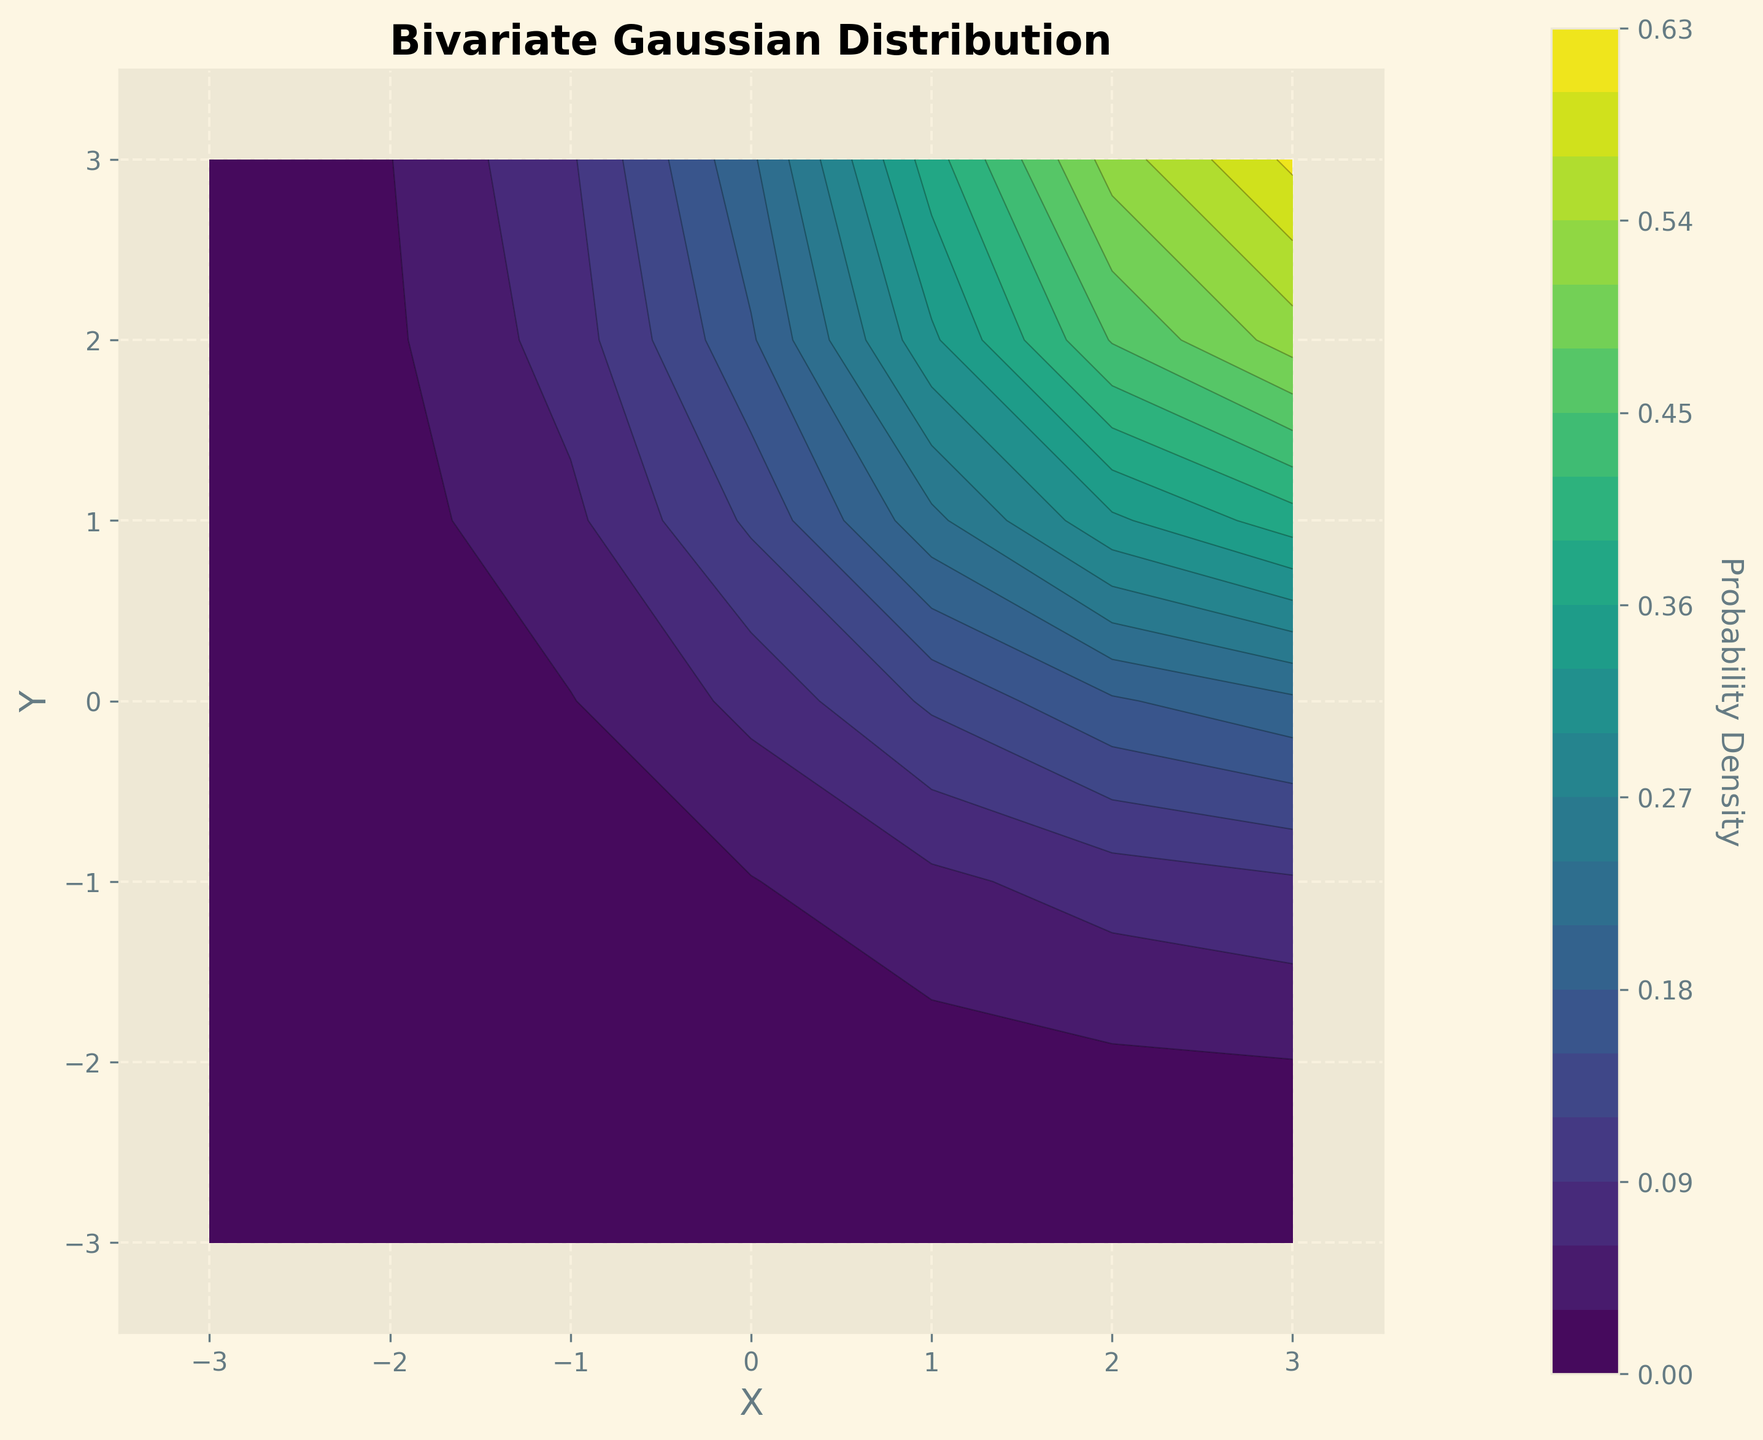What is the title of the figure? The title of the figure is displayed at the top and indicates what the plot represents. Looking at the label, we see the title is "Bivariate Gaussian Distribution."
Answer: Bivariate Gaussian Distribution What are the labels for the x-axis and y-axis? The labels for the axes are found directly adjacent to the respective axes along the plot margins. They indicate what the axes represent. The x-axis is labeled "X," and the y-axis is labeled "Y."
Answer: X and Y What does the color in the contour plot indicate? The contour plot uses color to represent different values on a continuous scale. The color bar on the right side of the plot indicates that the color represents the probability density values.
Answer: Probability Density Which color represents the highest probability density? Observing the color bar, the highest probability density is reflected by the color at the top end of the scale. In this case, it is a lighter to yellowish color in the 'viridis' color map.
Answer: Light yellow Where is the peak of the bivariate Gaussian distribution located, based on the plot? The peak of the distribution is the point where the probability density is highest. From the plot, we see that the lightest color (indicating the highest density) is centered around the origin (0,0).
Answer: At (0,0) What is the approximate probability density value at (2,2)? To determine this, locate the point (2,2) on the plot, and use the color and the color bar to estimate the probability density value. The color at (2,2) is dark green. According to the color bar, this corresponds to approximately 0.45.
Answer: 0.45 Compare the probability densities at points (1,1) and (3,3). Which is higher? To compare them, locate both points on the plot and refer to the color of each. The point (1,1) has a yellowish color, corresponding to a higher value on the color bar than the greenish color seen at (3,3).
Answer: (1,1) is higher What symmetry properties can you observe in the plot? Reviewing the plot, we can see if the contours and colors are symmetric around the origin (0,0). The plot appears to be symmetric with respect to both the x-axis and y-axis, which is typical for a bivariate Gaussian distribution centered at the origin.
Answer: Symmetric around the origin Describe the relationship between the distance from the origin and the probability density. Observing the trend in the contour plot, as you move further away from the origin (0,0), the probability density decreases. This is evident from the color transitioning to darker shades.
Answer: Decreases with distance from the origin 